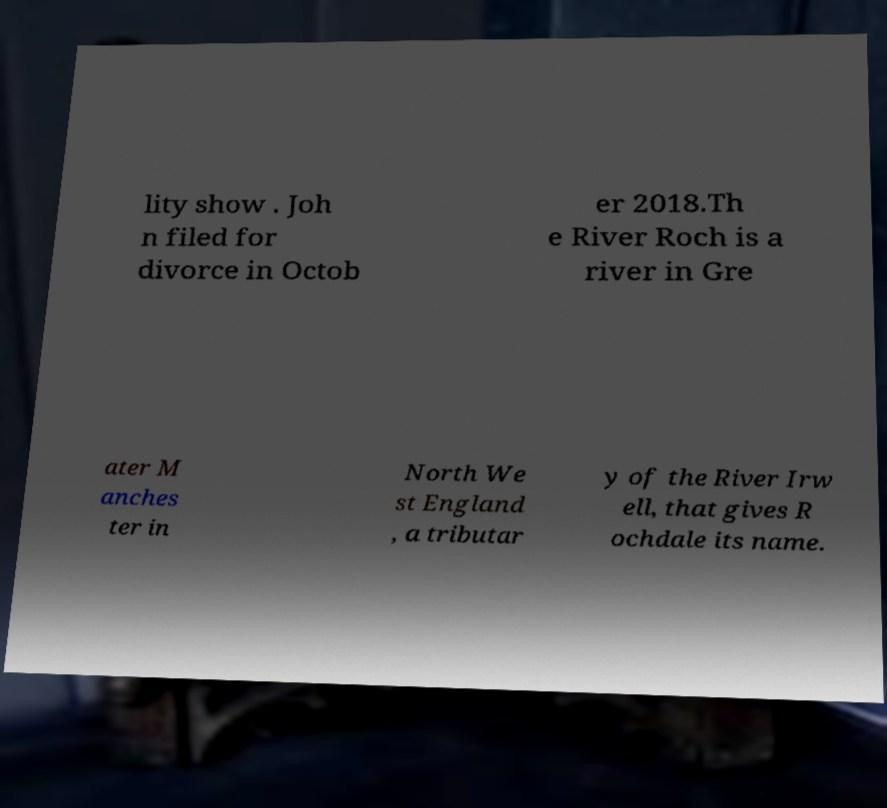Could you assist in decoding the text presented in this image and type it out clearly? lity show . Joh n filed for divorce in Octob er 2018.Th e River Roch is a river in Gre ater M anches ter in North We st England , a tributar y of the River Irw ell, that gives R ochdale its name. 